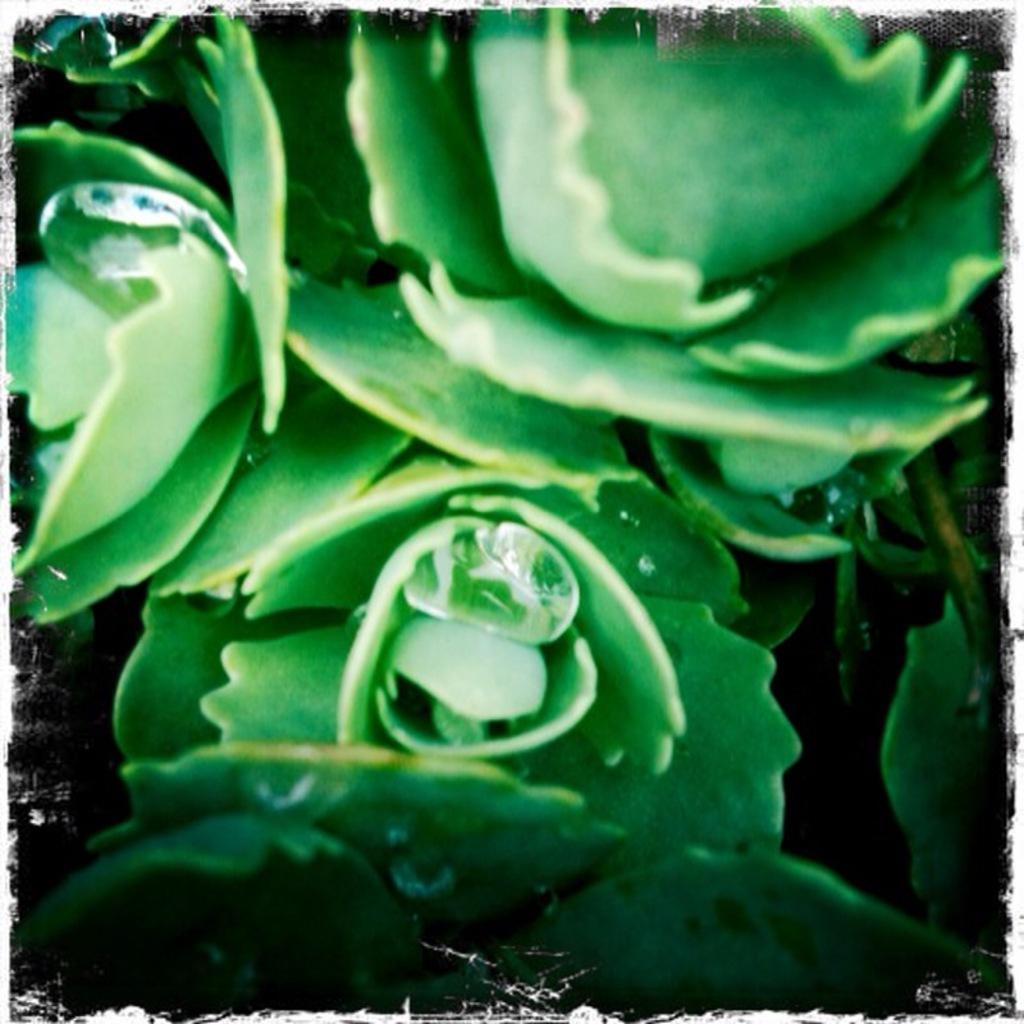What type of living organism can be seen in the image? There is a plant in the image. What type of chalk is the girl using to draw on the clam in the image? There is no girl, chalk, or clam present in the image; it only features a plant. 